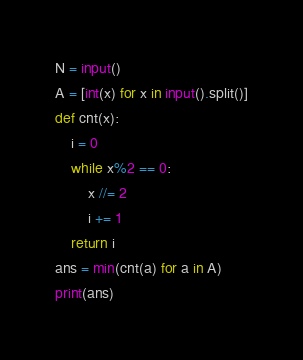Convert code to text. <code><loc_0><loc_0><loc_500><loc_500><_Python_>N = input()
A = [int(x) for x in input().split()]
def cnt(x):
    i = 0
    while x%2 == 0:
        x //= 2
        i += 1
    return i
ans = min(cnt(a) for a in A)
print(ans)</code> 